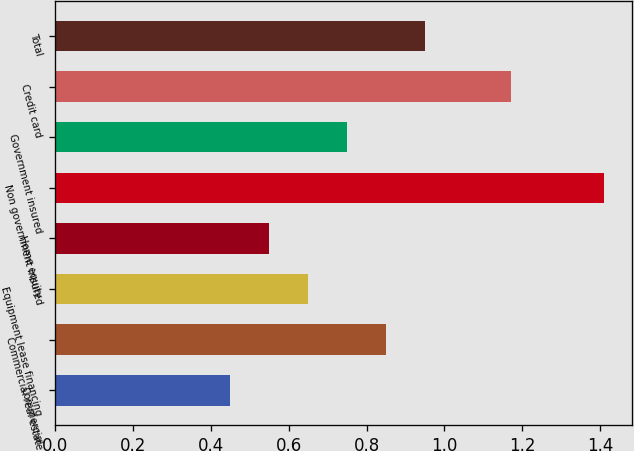Convert chart to OTSL. <chart><loc_0><loc_0><loc_500><loc_500><bar_chart><fcel>Commercial<fcel>Commercial real estate<fcel>Equipment lease financing<fcel>Home equity<fcel>Non government insured<fcel>Government insured<fcel>Credit card<fcel>Total<nl><fcel>0.45<fcel>0.85<fcel>0.65<fcel>0.55<fcel>1.41<fcel>0.75<fcel>1.17<fcel>0.95<nl></chart> 